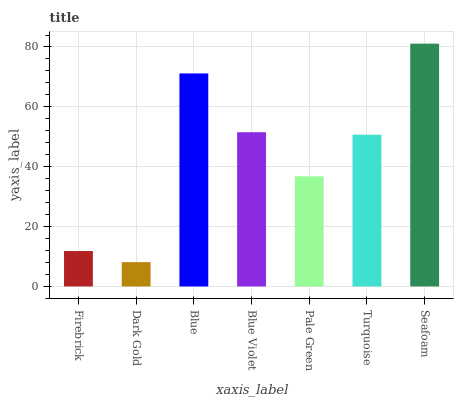Is Dark Gold the minimum?
Answer yes or no. Yes. Is Seafoam the maximum?
Answer yes or no. Yes. Is Blue the minimum?
Answer yes or no. No. Is Blue the maximum?
Answer yes or no. No. Is Blue greater than Dark Gold?
Answer yes or no. Yes. Is Dark Gold less than Blue?
Answer yes or no. Yes. Is Dark Gold greater than Blue?
Answer yes or no. No. Is Blue less than Dark Gold?
Answer yes or no. No. Is Turquoise the high median?
Answer yes or no. Yes. Is Turquoise the low median?
Answer yes or no. Yes. Is Firebrick the high median?
Answer yes or no. No. Is Seafoam the low median?
Answer yes or no. No. 